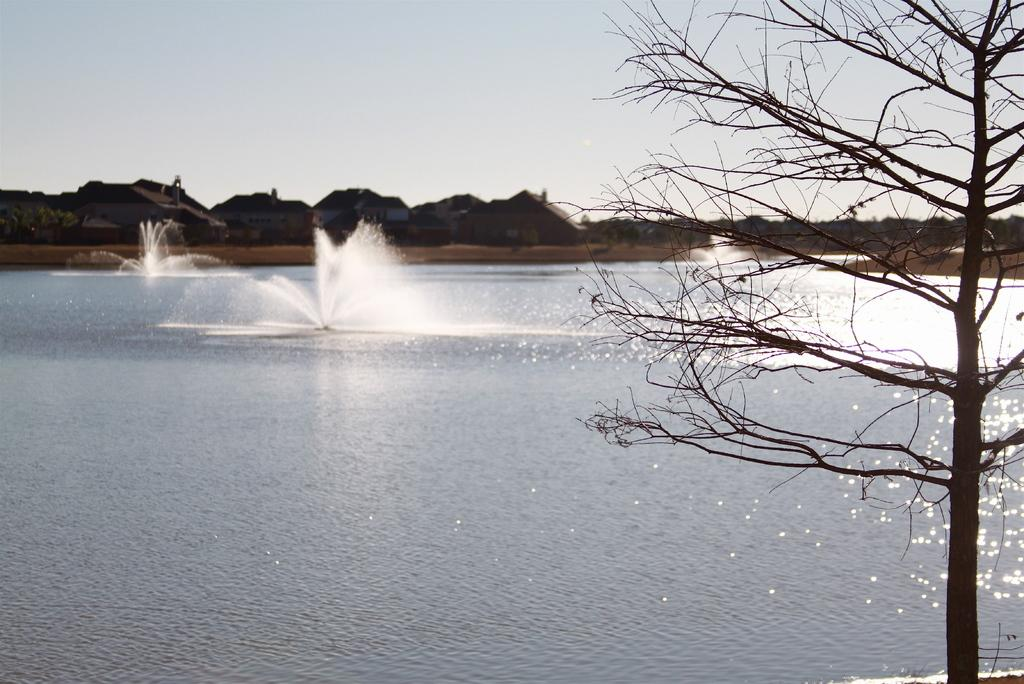What is located on the right side of the image? There is a tree on the right side of the image. What can be seen in the background of the image? There are trees and buildings in the background of the image. What is visible on the ground in the image? The ground is visible in the background of the image. What is present in the sky in the image? There are clouds in the sky. What type of brick is being used to build the giraffe in the image? There is no giraffe or brick present in the image. Where can the underwear be found in the image? There is no underwear present in the image. 